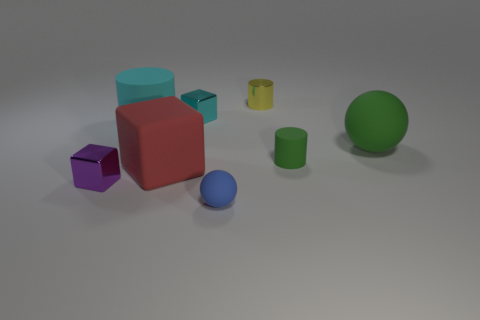There is a tiny thing that is the same color as the large cylinder; what is its material?
Your response must be concise. Metal. How many large matte things are the same shape as the small cyan metallic thing?
Offer a terse response. 1. Is the material of the yellow object the same as the ball in front of the purple block?
Offer a very short reply. No. What is the material of the yellow object that is the same size as the purple cube?
Provide a short and direct response. Metal. Is there a blue ball of the same size as the red thing?
Provide a succinct answer. No. There is a purple thing that is the same size as the yellow metal cylinder; what is its shape?
Provide a succinct answer. Cube. How many other objects are there of the same color as the big cube?
Ensure brevity in your answer.  0. There is a small thing that is both on the right side of the tiny blue sphere and on the left side of the green matte cylinder; what shape is it?
Your answer should be compact. Cylinder. Is there a small matte cylinder that is behind the tiny rubber thing that is behind the sphere that is on the left side of the green cylinder?
Your answer should be compact. No. How many other objects are there of the same material as the large cylinder?
Your answer should be very brief. 4. 